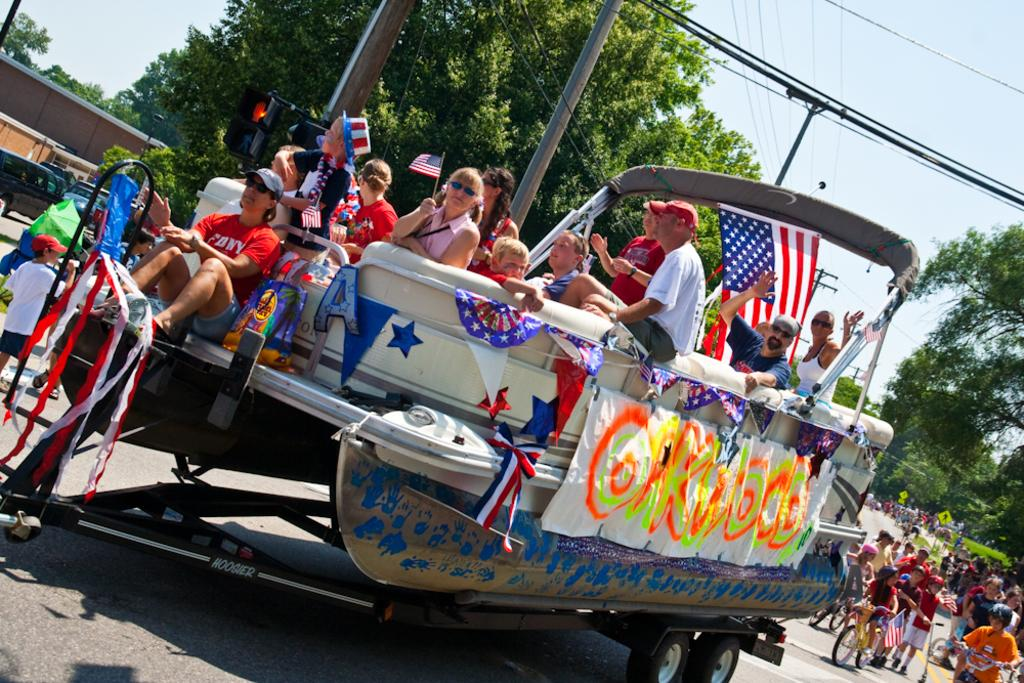<image>
Write a terse but informative summary of the picture. a boat that is on top of the road with the letter O on it 